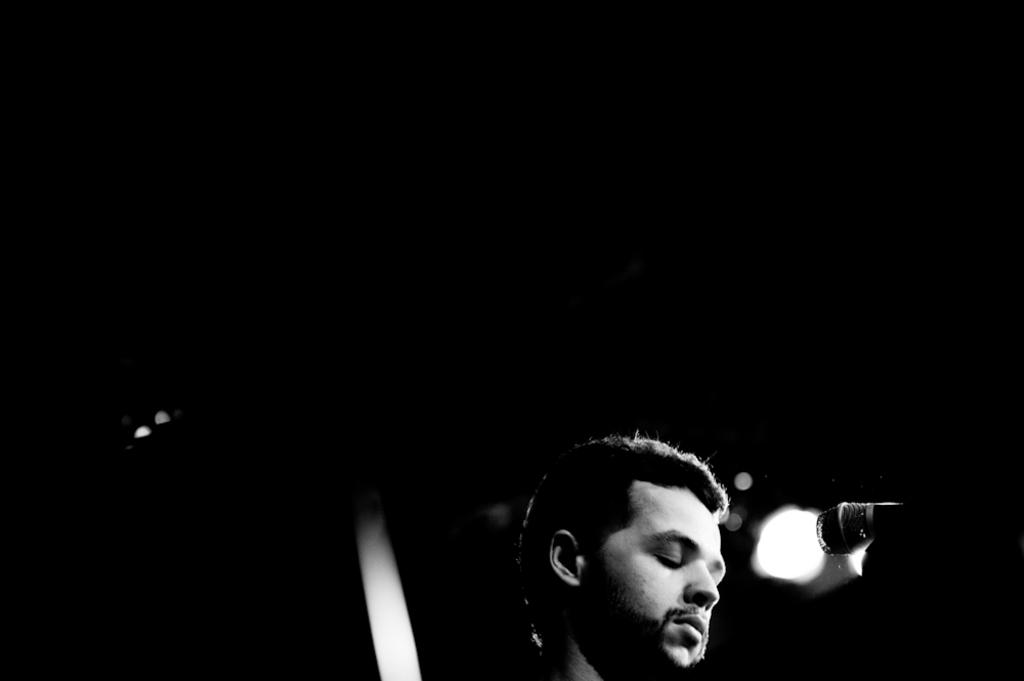What is the main subject of the image? There is a person standing in the image. What is the person holding in the image? The person is holding a microphone. How would you describe the background of the image? The backdrop of the image is dark. What color scheme is used in the image? The image is black and white. What day of the week is depicted on the calendar in the image? There is no calendar present in the image. What is the condition of the thing on the left side of the image? There is no thing on the left side of the image, and therefore no condition can be determined. 